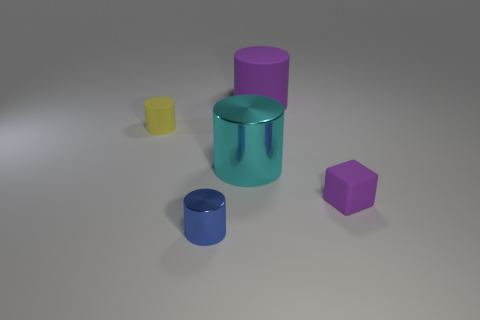Subtract all cyan cylinders. How many cylinders are left? 3 Add 3 cyan things. How many objects exist? 8 Subtract all purple cylinders. How many cylinders are left? 3 Subtract all cylinders. How many objects are left? 1 Add 3 purple objects. How many purple objects exist? 5 Subtract 0 green blocks. How many objects are left? 5 Subtract 1 cubes. How many cubes are left? 0 Subtract all red cylinders. Subtract all green balls. How many cylinders are left? 4 Subtract all small red metal cylinders. Subtract all metallic objects. How many objects are left? 3 Add 4 big purple matte cylinders. How many big purple matte cylinders are left? 5 